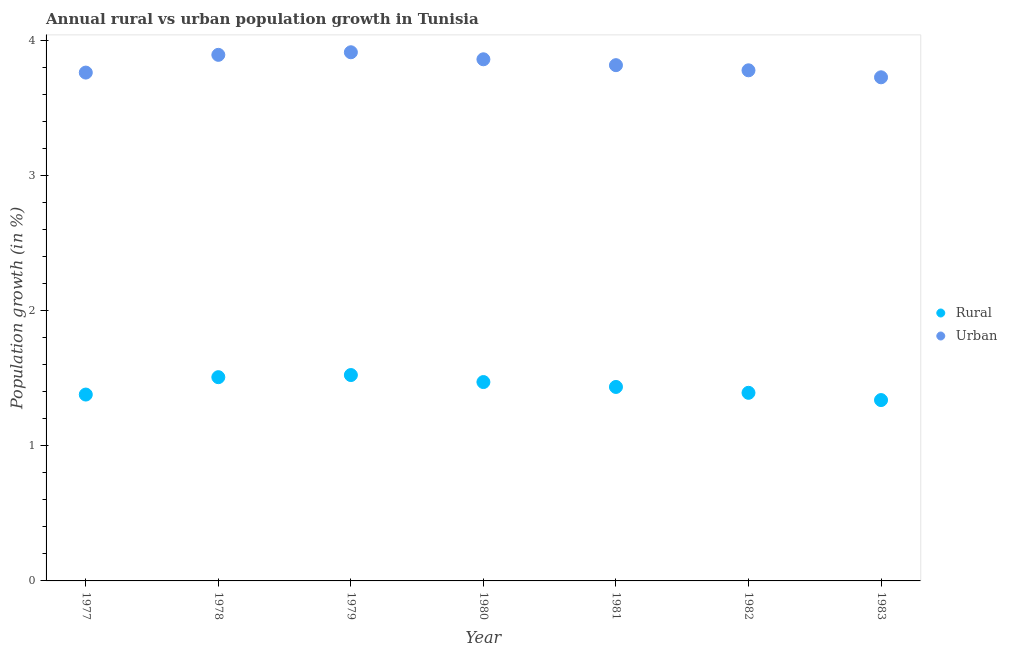What is the urban population growth in 1978?
Provide a short and direct response. 3.89. Across all years, what is the maximum urban population growth?
Your answer should be very brief. 3.91. Across all years, what is the minimum rural population growth?
Provide a short and direct response. 1.34. In which year was the urban population growth maximum?
Your answer should be compact. 1979. In which year was the rural population growth minimum?
Offer a very short reply. 1983. What is the total rural population growth in the graph?
Provide a short and direct response. 10.05. What is the difference between the rural population growth in 1977 and that in 1982?
Keep it short and to the point. -0.01. What is the difference between the urban population growth in 1979 and the rural population growth in 1980?
Your answer should be compact. 2.44. What is the average urban population growth per year?
Offer a terse response. 3.82. In the year 1982, what is the difference between the rural population growth and urban population growth?
Give a very brief answer. -2.39. In how many years, is the rural population growth greater than 1.6 %?
Your answer should be very brief. 0. What is the ratio of the rural population growth in 1978 to that in 1982?
Ensure brevity in your answer.  1.08. Is the difference between the urban population growth in 1978 and 1980 greater than the difference between the rural population growth in 1978 and 1980?
Provide a succinct answer. No. What is the difference between the highest and the second highest urban population growth?
Make the answer very short. 0.02. What is the difference between the highest and the lowest urban population growth?
Your answer should be compact. 0.19. Is the sum of the rural population growth in 1979 and 1981 greater than the maximum urban population growth across all years?
Your answer should be compact. No. Does the rural population growth monotonically increase over the years?
Offer a terse response. No. Is the rural population growth strictly less than the urban population growth over the years?
Your answer should be compact. Yes. How many dotlines are there?
Your answer should be compact. 2. How many years are there in the graph?
Offer a very short reply. 7. Does the graph contain any zero values?
Give a very brief answer. No. What is the title of the graph?
Your response must be concise. Annual rural vs urban population growth in Tunisia. Does "Male labor force" appear as one of the legend labels in the graph?
Your response must be concise. No. What is the label or title of the Y-axis?
Make the answer very short. Population growth (in %). What is the Population growth (in %) of Rural in 1977?
Ensure brevity in your answer.  1.38. What is the Population growth (in %) in Urban  in 1977?
Keep it short and to the point. 3.76. What is the Population growth (in %) in Rural in 1978?
Provide a short and direct response. 1.51. What is the Population growth (in %) in Urban  in 1978?
Give a very brief answer. 3.89. What is the Population growth (in %) in Rural in 1979?
Ensure brevity in your answer.  1.52. What is the Population growth (in %) of Urban  in 1979?
Your response must be concise. 3.91. What is the Population growth (in %) in Rural in 1980?
Provide a succinct answer. 1.47. What is the Population growth (in %) in Urban  in 1980?
Offer a very short reply. 3.86. What is the Population growth (in %) of Rural in 1981?
Your answer should be very brief. 1.44. What is the Population growth (in %) in Urban  in 1981?
Provide a short and direct response. 3.82. What is the Population growth (in %) in Rural in 1982?
Provide a succinct answer. 1.39. What is the Population growth (in %) of Urban  in 1982?
Provide a short and direct response. 3.78. What is the Population growth (in %) of Rural in 1983?
Offer a terse response. 1.34. What is the Population growth (in %) of Urban  in 1983?
Your answer should be compact. 3.73. Across all years, what is the maximum Population growth (in %) of Rural?
Provide a succinct answer. 1.52. Across all years, what is the maximum Population growth (in %) in Urban ?
Your answer should be compact. 3.91. Across all years, what is the minimum Population growth (in %) in Rural?
Offer a very short reply. 1.34. Across all years, what is the minimum Population growth (in %) of Urban ?
Your answer should be compact. 3.73. What is the total Population growth (in %) in Rural in the graph?
Your response must be concise. 10.05. What is the total Population growth (in %) of Urban  in the graph?
Make the answer very short. 26.74. What is the difference between the Population growth (in %) of Rural in 1977 and that in 1978?
Make the answer very short. -0.13. What is the difference between the Population growth (in %) of Urban  in 1977 and that in 1978?
Offer a very short reply. -0.13. What is the difference between the Population growth (in %) in Rural in 1977 and that in 1979?
Ensure brevity in your answer.  -0.14. What is the difference between the Population growth (in %) of Urban  in 1977 and that in 1979?
Your answer should be very brief. -0.15. What is the difference between the Population growth (in %) in Rural in 1977 and that in 1980?
Your response must be concise. -0.09. What is the difference between the Population growth (in %) in Urban  in 1977 and that in 1980?
Your answer should be very brief. -0.1. What is the difference between the Population growth (in %) of Rural in 1977 and that in 1981?
Ensure brevity in your answer.  -0.06. What is the difference between the Population growth (in %) of Urban  in 1977 and that in 1981?
Offer a terse response. -0.05. What is the difference between the Population growth (in %) of Rural in 1977 and that in 1982?
Provide a short and direct response. -0.01. What is the difference between the Population growth (in %) of Urban  in 1977 and that in 1982?
Give a very brief answer. -0.02. What is the difference between the Population growth (in %) in Rural in 1977 and that in 1983?
Your answer should be compact. 0.04. What is the difference between the Population growth (in %) in Urban  in 1977 and that in 1983?
Give a very brief answer. 0.03. What is the difference between the Population growth (in %) in Rural in 1978 and that in 1979?
Ensure brevity in your answer.  -0.02. What is the difference between the Population growth (in %) in Urban  in 1978 and that in 1979?
Your answer should be compact. -0.02. What is the difference between the Population growth (in %) of Rural in 1978 and that in 1980?
Your answer should be very brief. 0.04. What is the difference between the Population growth (in %) in Urban  in 1978 and that in 1980?
Offer a very short reply. 0.03. What is the difference between the Population growth (in %) of Rural in 1978 and that in 1981?
Your answer should be compact. 0.07. What is the difference between the Population growth (in %) in Urban  in 1978 and that in 1981?
Provide a short and direct response. 0.08. What is the difference between the Population growth (in %) in Rural in 1978 and that in 1982?
Offer a terse response. 0.12. What is the difference between the Population growth (in %) in Urban  in 1978 and that in 1982?
Your answer should be very brief. 0.11. What is the difference between the Population growth (in %) in Rural in 1978 and that in 1983?
Your response must be concise. 0.17. What is the difference between the Population growth (in %) in Urban  in 1978 and that in 1983?
Make the answer very short. 0.17. What is the difference between the Population growth (in %) of Rural in 1979 and that in 1980?
Make the answer very short. 0.05. What is the difference between the Population growth (in %) of Urban  in 1979 and that in 1980?
Offer a terse response. 0.05. What is the difference between the Population growth (in %) in Rural in 1979 and that in 1981?
Your answer should be very brief. 0.09. What is the difference between the Population growth (in %) in Urban  in 1979 and that in 1981?
Your answer should be very brief. 0.1. What is the difference between the Population growth (in %) in Rural in 1979 and that in 1982?
Give a very brief answer. 0.13. What is the difference between the Population growth (in %) in Urban  in 1979 and that in 1982?
Provide a short and direct response. 0.13. What is the difference between the Population growth (in %) in Rural in 1979 and that in 1983?
Provide a short and direct response. 0.19. What is the difference between the Population growth (in %) in Urban  in 1979 and that in 1983?
Ensure brevity in your answer.  0.19. What is the difference between the Population growth (in %) in Rural in 1980 and that in 1981?
Offer a terse response. 0.04. What is the difference between the Population growth (in %) of Urban  in 1980 and that in 1981?
Offer a very short reply. 0.04. What is the difference between the Population growth (in %) of Rural in 1980 and that in 1982?
Provide a short and direct response. 0.08. What is the difference between the Population growth (in %) in Urban  in 1980 and that in 1982?
Offer a very short reply. 0.08. What is the difference between the Population growth (in %) of Rural in 1980 and that in 1983?
Offer a very short reply. 0.13. What is the difference between the Population growth (in %) of Urban  in 1980 and that in 1983?
Offer a terse response. 0.13. What is the difference between the Population growth (in %) in Rural in 1981 and that in 1982?
Your response must be concise. 0.04. What is the difference between the Population growth (in %) of Urban  in 1981 and that in 1982?
Make the answer very short. 0.04. What is the difference between the Population growth (in %) of Rural in 1981 and that in 1983?
Give a very brief answer. 0.1. What is the difference between the Population growth (in %) of Urban  in 1981 and that in 1983?
Your answer should be very brief. 0.09. What is the difference between the Population growth (in %) in Rural in 1982 and that in 1983?
Give a very brief answer. 0.05. What is the difference between the Population growth (in %) of Urban  in 1982 and that in 1983?
Offer a terse response. 0.05. What is the difference between the Population growth (in %) of Rural in 1977 and the Population growth (in %) of Urban  in 1978?
Provide a short and direct response. -2.51. What is the difference between the Population growth (in %) of Rural in 1977 and the Population growth (in %) of Urban  in 1979?
Your answer should be very brief. -2.53. What is the difference between the Population growth (in %) of Rural in 1977 and the Population growth (in %) of Urban  in 1980?
Ensure brevity in your answer.  -2.48. What is the difference between the Population growth (in %) in Rural in 1977 and the Population growth (in %) in Urban  in 1981?
Ensure brevity in your answer.  -2.44. What is the difference between the Population growth (in %) in Rural in 1977 and the Population growth (in %) in Urban  in 1982?
Make the answer very short. -2.4. What is the difference between the Population growth (in %) of Rural in 1977 and the Population growth (in %) of Urban  in 1983?
Your answer should be compact. -2.35. What is the difference between the Population growth (in %) of Rural in 1978 and the Population growth (in %) of Urban  in 1979?
Make the answer very short. -2.4. What is the difference between the Population growth (in %) in Rural in 1978 and the Population growth (in %) in Urban  in 1980?
Make the answer very short. -2.35. What is the difference between the Population growth (in %) in Rural in 1978 and the Population growth (in %) in Urban  in 1981?
Give a very brief answer. -2.31. What is the difference between the Population growth (in %) of Rural in 1978 and the Population growth (in %) of Urban  in 1982?
Ensure brevity in your answer.  -2.27. What is the difference between the Population growth (in %) of Rural in 1978 and the Population growth (in %) of Urban  in 1983?
Ensure brevity in your answer.  -2.22. What is the difference between the Population growth (in %) of Rural in 1979 and the Population growth (in %) of Urban  in 1980?
Offer a very short reply. -2.34. What is the difference between the Population growth (in %) in Rural in 1979 and the Population growth (in %) in Urban  in 1981?
Your response must be concise. -2.29. What is the difference between the Population growth (in %) in Rural in 1979 and the Population growth (in %) in Urban  in 1982?
Your response must be concise. -2.25. What is the difference between the Population growth (in %) in Rural in 1979 and the Population growth (in %) in Urban  in 1983?
Provide a succinct answer. -2.2. What is the difference between the Population growth (in %) of Rural in 1980 and the Population growth (in %) of Urban  in 1981?
Your answer should be very brief. -2.34. What is the difference between the Population growth (in %) in Rural in 1980 and the Population growth (in %) in Urban  in 1982?
Keep it short and to the point. -2.31. What is the difference between the Population growth (in %) in Rural in 1980 and the Population growth (in %) in Urban  in 1983?
Ensure brevity in your answer.  -2.25. What is the difference between the Population growth (in %) in Rural in 1981 and the Population growth (in %) in Urban  in 1982?
Make the answer very short. -2.34. What is the difference between the Population growth (in %) in Rural in 1981 and the Population growth (in %) in Urban  in 1983?
Keep it short and to the point. -2.29. What is the difference between the Population growth (in %) of Rural in 1982 and the Population growth (in %) of Urban  in 1983?
Provide a succinct answer. -2.33. What is the average Population growth (in %) of Rural per year?
Offer a very short reply. 1.44. What is the average Population growth (in %) in Urban  per year?
Offer a very short reply. 3.82. In the year 1977, what is the difference between the Population growth (in %) in Rural and Population growth (in %) in Urban ?
Make the answer very short. -2.38. In the year 1978, what is the difference between the Population growth (in %) of Rural and Population growth (in %) of Urban ?
Your answer should be compact. -2.38. In the year 1979, what is the difference between the Population growth (in %) of Rural and Population growth (in %) of Urban ?
Offer a very short reply. -2.39. In the year 1980, what is the difference between the Population growth (in %) in Rural and Population growth (in %) in Urban ?
Provide a short and direct response. -2.39. In the year 1981, what is the difference between the Population growth (in %) in Rural and Population growth (in %) in Urban ?
Your answer should be compact. -2.38. In the year 1982, what is the difference between the Population growth (in %) of Rural and Population growth (in %) of Urban ?
Offer a very short reply. -2.39. In the year 1983, what is the difference between the Population growth (in %) of Rural and Population growth (in %) of Urban ?
Ensure brevity in your answer.  -2.39. What is the ratio of the Population growth (in %) of Rural in 1977 to that in 1978?
Provide a succinct answer. 0.91. What is the ratio of the Population growth (in %) of Urban  in 1977 to that in 1978?
Provide a succinct answer. 0.97. What is the ratio of the Population growth (in %) in Rural in 1977 to that in 1979?
Offer a very short reply. 0.91. What is the ratio of the Population growth (in %) in Urban  in 1977 to that in 1979?
Offer a very short reply. 0.96. What is the ratio of the Population growth (in %) in Rural in 1977 to that in 1980?
Provide a succinct answer. 0.94. What is the ratio of the Population growth (in %) of Urban  in 1977 to that in 1980?
Offer a very short reply. 0.97. What is the ratio of the Population growth (in %) in Rural in 1977 to that in 1981?
Ensure brevity in your answer.  0.96. What is the ratio of the Population growth (in %) of Urban  in 1977 to that in 1981?
Ensure brevity in your answer.  0.99. What is the ratio of the Population growth (in %) in Rural in 1977 to that in 1982?
Your answer should be compact. 0.99. What is the ratio of the Population growth (in %) of Rural in 1977 to that in 1983?
Provide a short and direct response. 1.03. What is the ratio of the Population growth (in %) in Urban  in 1977 to that in 1983?
Provide a short and direct response. 1.01. What is the ratio of the Population growth (in %) in Rural in 1978 to that in 1980?
Keep it short and to the point. 1.02. What is the ratio of the Population growth (in %) of Urban  in 1978 to that in 1980?
Keep it short and to the point. 1.01. What is the ratio of the Population growth (in %) of Rural in 1978 to that in 1981?
Your answer should be very brief. 1.05. What is the ratio of the Population growth (in %) of Urban  in 1978 to that in 1981?
Provide a short and direct response. 1.02. What is the ratio of the Population growth (in %) in Rural in 1978 to that in 1982?
Your answer should be very brief. 1.08. What is the ratio of the Population growth (in %) in Urban  in 1978 to that in 1982?
Provide a succinct answer. 1.03. What is the ratio of the Population growth (in %) in Rural in 1978 to that in 1983?
Offer a very short reply. 1.13. What is the ratio of the Population growth (in %) in Urban  in 1978 to that in 1983?
Offer a terse response. 1.04. What is the ratio of the Population growth (in %) of Rural in 1979 to that in 1980?
Give a very brief answer. 1.04. What is the ratio of the Population growth (in %) of Urban  in 1979 to that in 1980?
Your response must be concise. 1.01. What is the ratio of the Population growth (in %) of Rural in 1979 to that in 1981?
Give a very brief answer. 1.06. What is the ratio of the Population growth (in %) of Rural in 1979 to that in 1982?
Provide a short and direct response. 1.09. What is the ratio of the Population growth (in %) in Urban  in 1979 to that in 1982?
Provide a succinct answer. 1.04. What is the ratio of the Population growth (in %) of Rural in 1979 to that in 1983?
Provide a short and direct response. 1.14. What is the ratio of the Population growth (in %) of Urban  in 1979 to that in 1983?
Ensure brevity in your answer.  1.05. What is the ratio of the Population growth (in %) in Rural in 1980 to that in 1981?
Offer a very short reply. 1.03. What is the ratio of the Population growth (in %) of Urban  in 1980 to that in 1981?
Keep it short and to the point. 1.01. What is the ratio of the Population growth (in %) of Rural in 1980 to that in 1982?
Your answer should be compact. 1.06. What is the ratio of the Population growth (in %) in Urban  in 1980 to that in 1982?
Give a very brief answer. 1.02. What is the ratio of the Population growth (in %) of Rural in 1980 to that in 1983?
Provide a succinct answer. 1.1. What is the ratio of the Population growth (in %) of Urban  in 1980 to that in 1983?
Keep it short and to the point. 1.04. What is the ratio of the Population growth (in %) in Rural in 1981 to that in 1982?
Make the answer very short. 1.03. What is the ratio of the Population growth (in %) in Urban  in 1981 to that in 1982?
Offer a terse response. 1.01. What is the ratio of the Population growth (in %) in Rural in 1981 to that in 1983?
Provide a succinct answer. 1.07. What is the ratio of the Population growth (in %) of Urban  in 1981 to that in 1983?
Ensure brevity in your answer.  1.02. What is the ratio of the Population growth (in %) in Rural in 1982 to that in 1983?
Ensure brevity in your answer.  1.04. What is the ratio of the Population growth (in %) of Urban  in 1982 to that in 1983?
Your answer should be very brief. 1.01. What is the difference between the highest and the second highest Population growth (in %) in Rural?
Your answer should be compact. 0.02. What is the difference between the highest and the second highest Population growth (in %) of Urban ?
Give a very brief answer. 0.02. What is the difference between the highest and the lowest Population growth (in %) in Rural?
Ensure brevity in your answer.  0.19. What is the difference between the highest and the lowest Population growth (in %) in Urban ?
Your answer should be very brief. 0.19. 